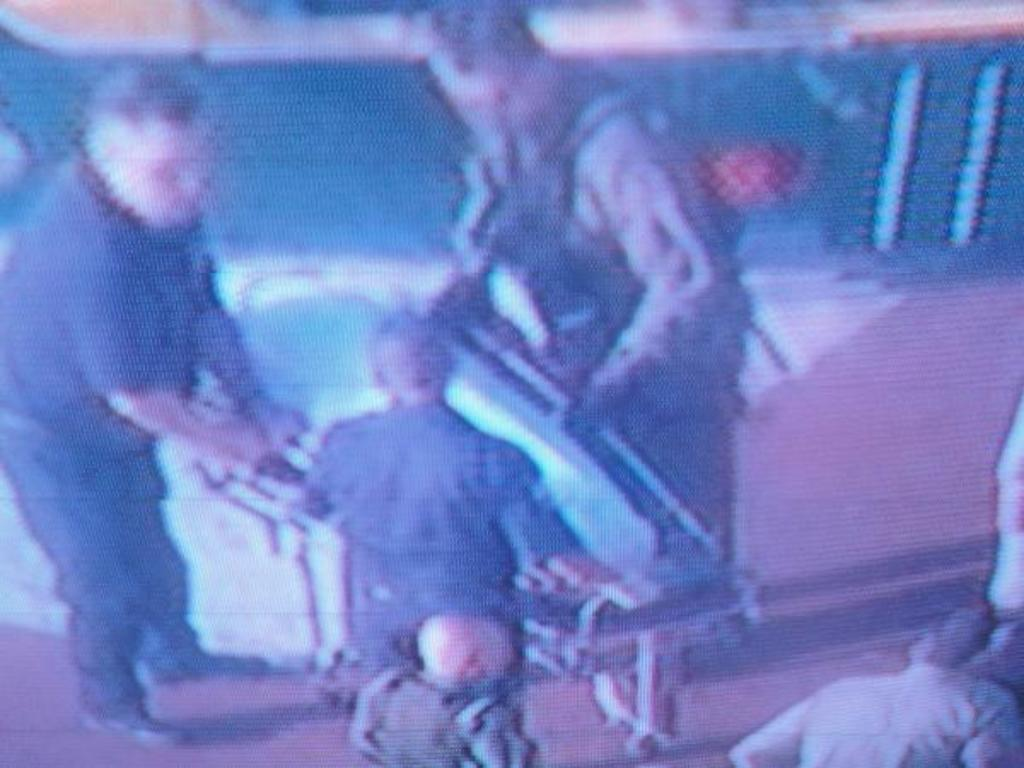What can be observed about the people in the image? There are people standing in the image. Can you describe the quality of the image? The image is blurred. What type of mark can be seen on the person's forehead in the image? There is no mark visible on anyone's forehead in the image. Is there a scarf draped around the neck of any person in the image? There is no mention of a scarf in the image. How many cherries are being held by the people in the image? There is no mention of cherries in the image. 